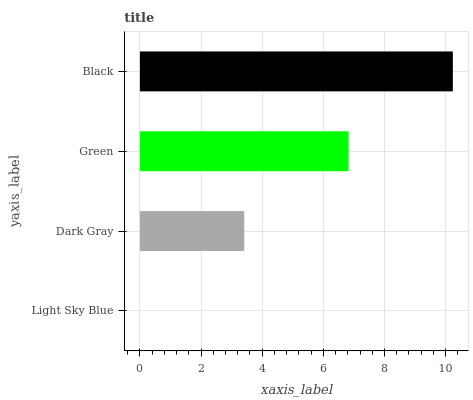Is Light Sky Blue the minimum?
Answer yes or no. Yes. Is Black the maximum?
Answer yes or no. Yes. Is Dark Gray the minimum?
Answer yes or no. No. Is Dark Gray the maximum?
Answer yes or no. No. Is Dark Gray greater than Light Sky Blue?
Answer yes or no. Yes. Is Light Sky Blue less than Dark Gray?
Answer yes or no. Yes. Is Light Sky Blue greater than Dark Gray?
Answer yes or no. No. Is Dark Gray less than Light Sky Blue?
Answer yes or no. No. Is Green the high median?
Answer yes or no. Yes. Is Dark Gray the low median?
Answer yes or no. Yes. Is Black the high median?
Answer yes or no. No. Is Black the low median?
Answer yes or no. No. 